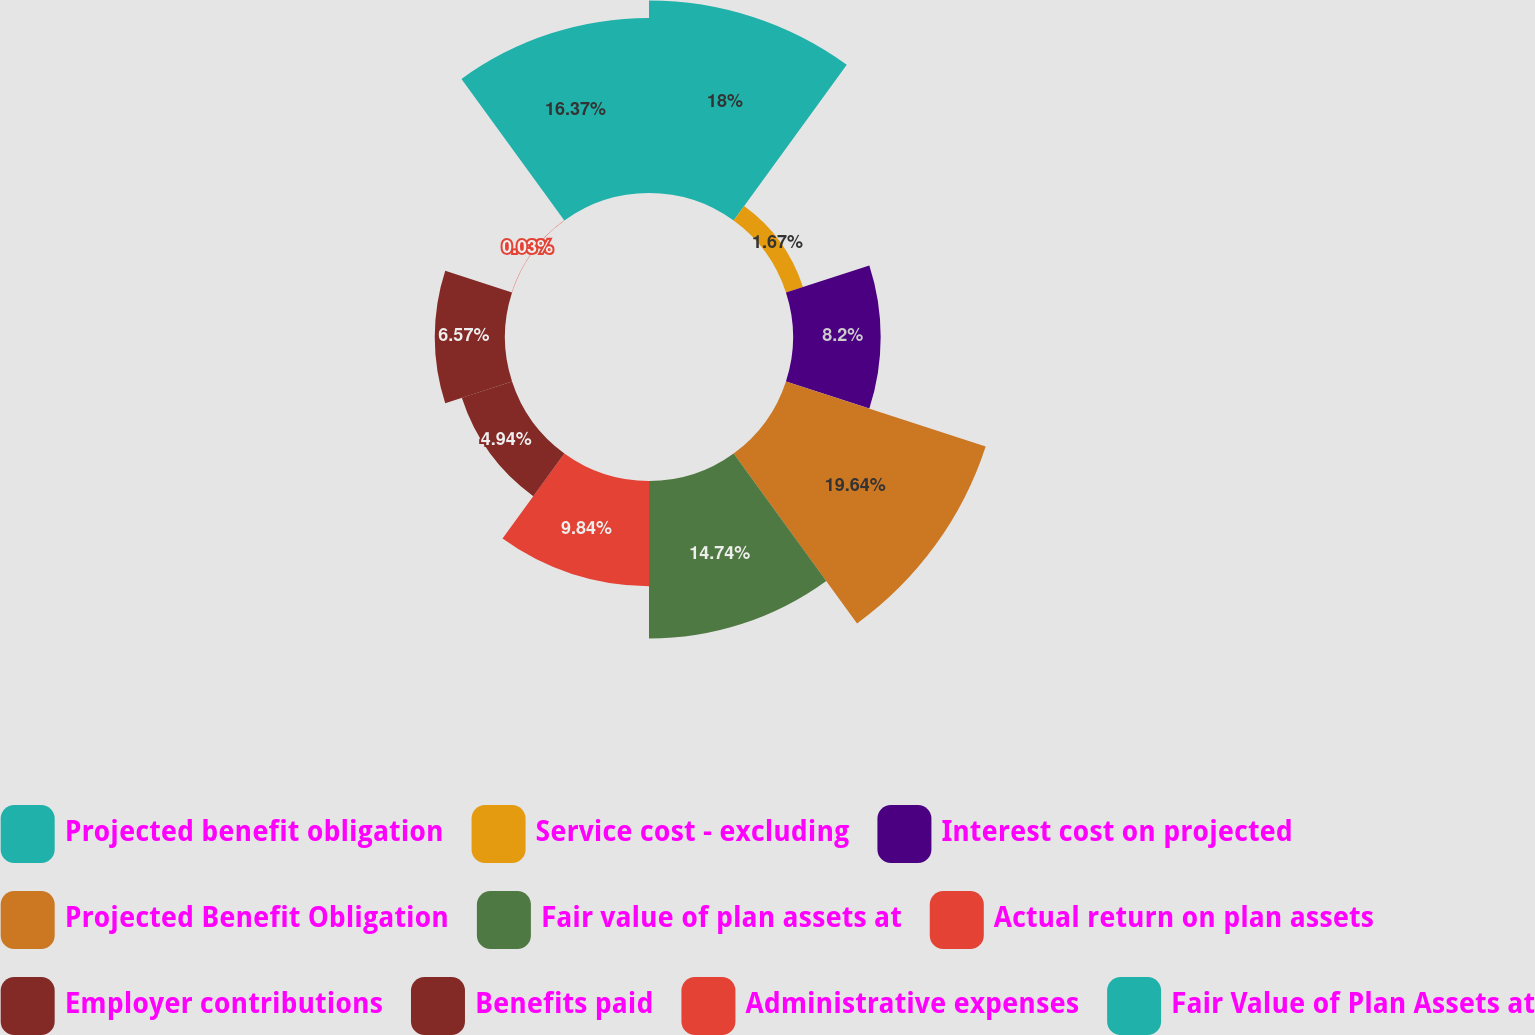<chart> <loc_0><loc_0><loc_500><loc_500><pie_chart><fcel>Projected benefit obligation<fcel>Service cost - excluding<fcel>Interest cost on projected<fcel>Projected Benefit Obligation<fcel>Fair value of plan assets at<fcel>Actual return on plan assets<fcel>Employer contributions<fcel>Benefits paid<fcel>Administrative expenses<fcel>Fair Value of Plan Assets at<nl><fcel>18.0%<fcel>1.67%<fcel>8.2%<fcel>19.64%<fcel>14.74%<fcel>9.84%<fcel>4.94%<fcel>6.57%<fcel>0.03%<fcel>16.37%<nl></chart> 